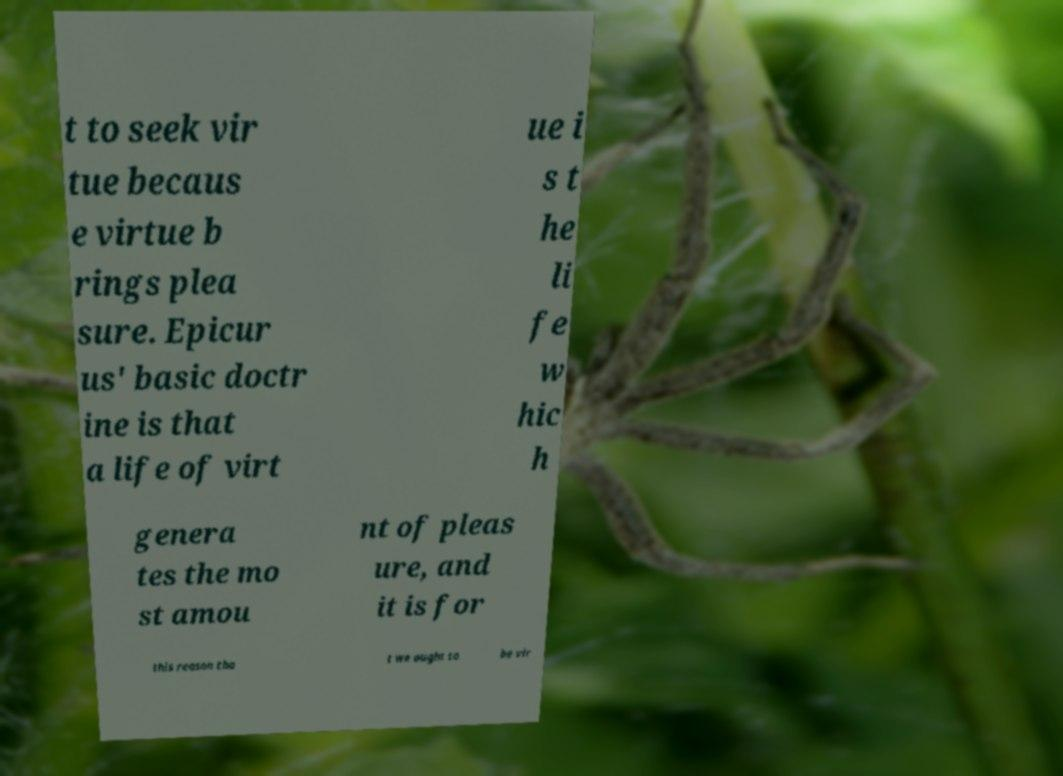For documentation purposes, I need the text within this image transcribed. Could you provide that? t to seek vir tue becaus e virtue b rings plea sure. Epicur us' basic doctr ine is that a life of virt ue i s t he li fe w hic h genera tes the mo st amou nt of pleas ure, and it is for this reason tha t we ought to be vir 